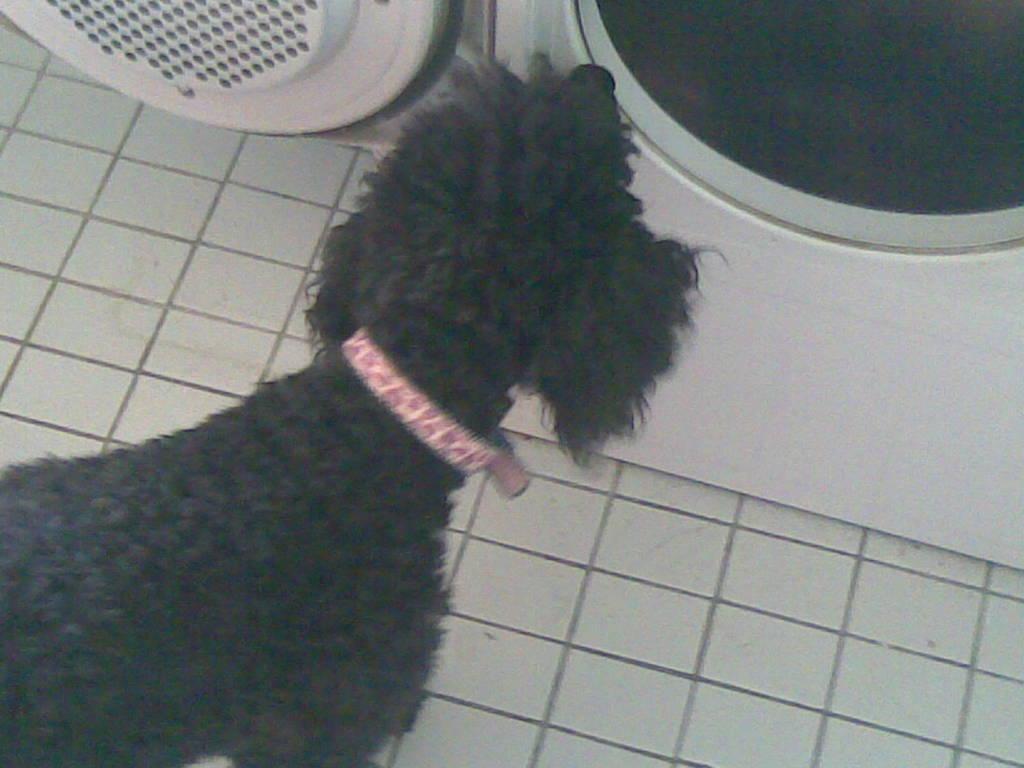Can you describe this image briefly? In this image I can see a dog which is black in color and a belt to its neck which is pink in color. I can see a washing machine which is white in color on the white colored floor. 